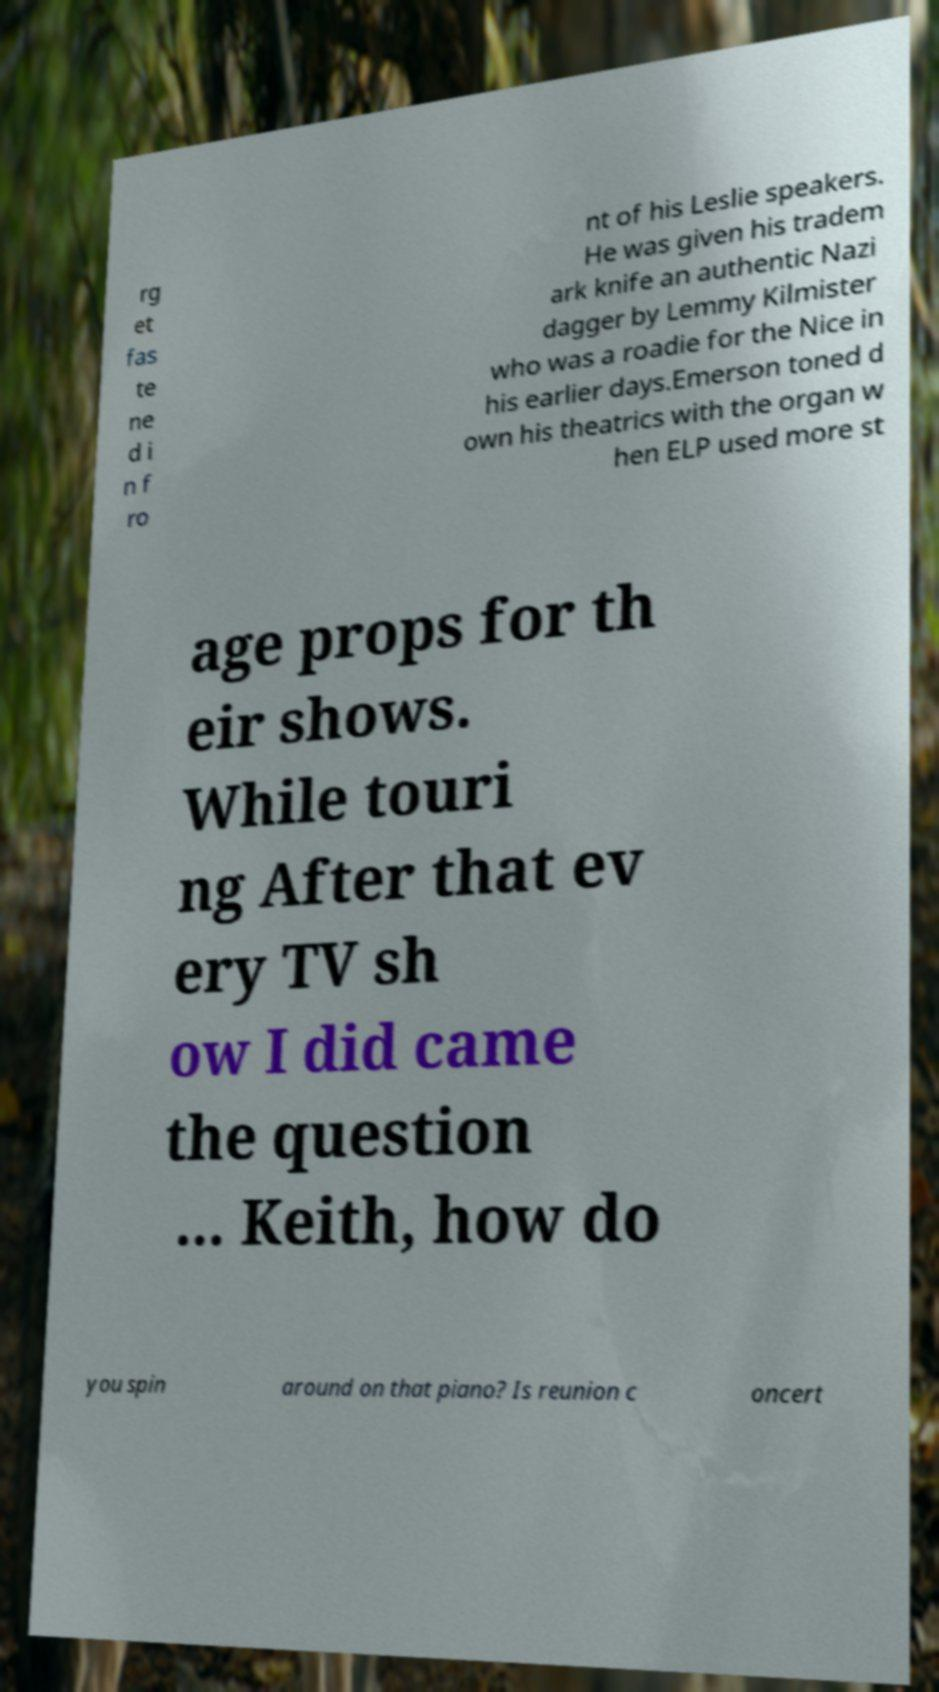There's text embedded in this image that I need extracted. Can you transcribe it verbatim? rg et fas te ne d i n f ro nt of his Leslie speakers. He was given his tradem ark knife an authentic Nazi dagger by Lemmy Kilmister who was a roadie for the Nice in his earlier days.Emerson toned d own his theatrics with the organ w hen ELP used more st age props for th eir shows. While touri ng After that ev ery TV sh ow I did came the question ... Keith, how do you spin around on that piano? Is reunion c oncert 